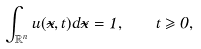<formula> <loc_0><loc_0><loc_500><loc_500>\int _ { \mathbb { R } ^ { n } } u ( \vec { x } , t ) d \vec { x } = 1 , \quad t \geqslant 0 ,</formula> 